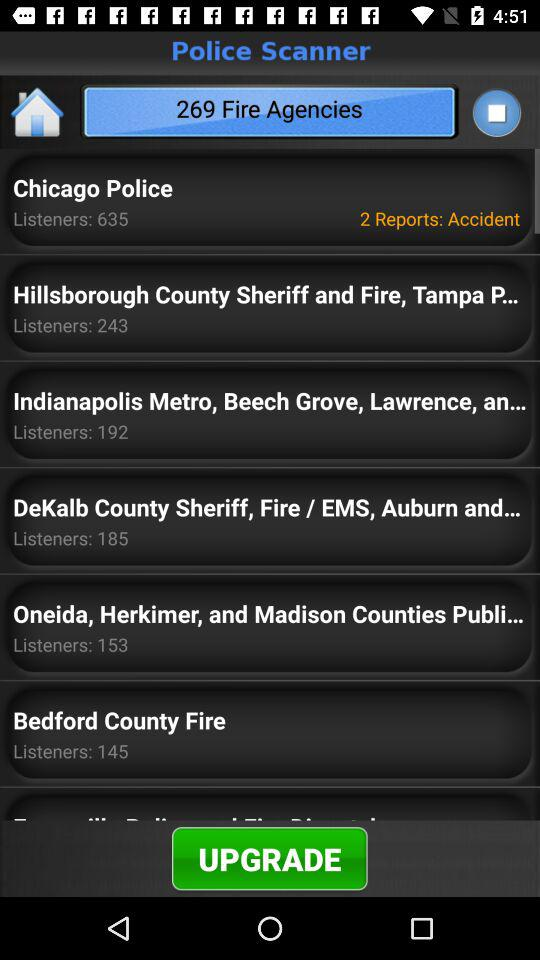What is the version number?
When the provided information is insufficient, respond with <no answer>. <no answer> 